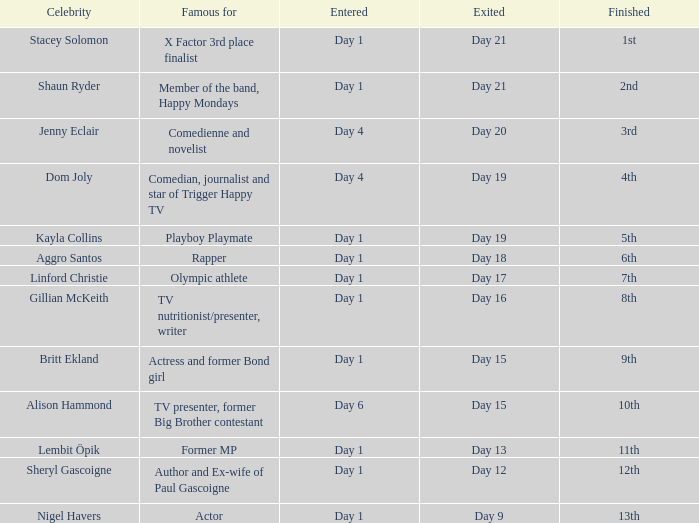Which celebrity was famous for being a rapper? Aggro Santos. 